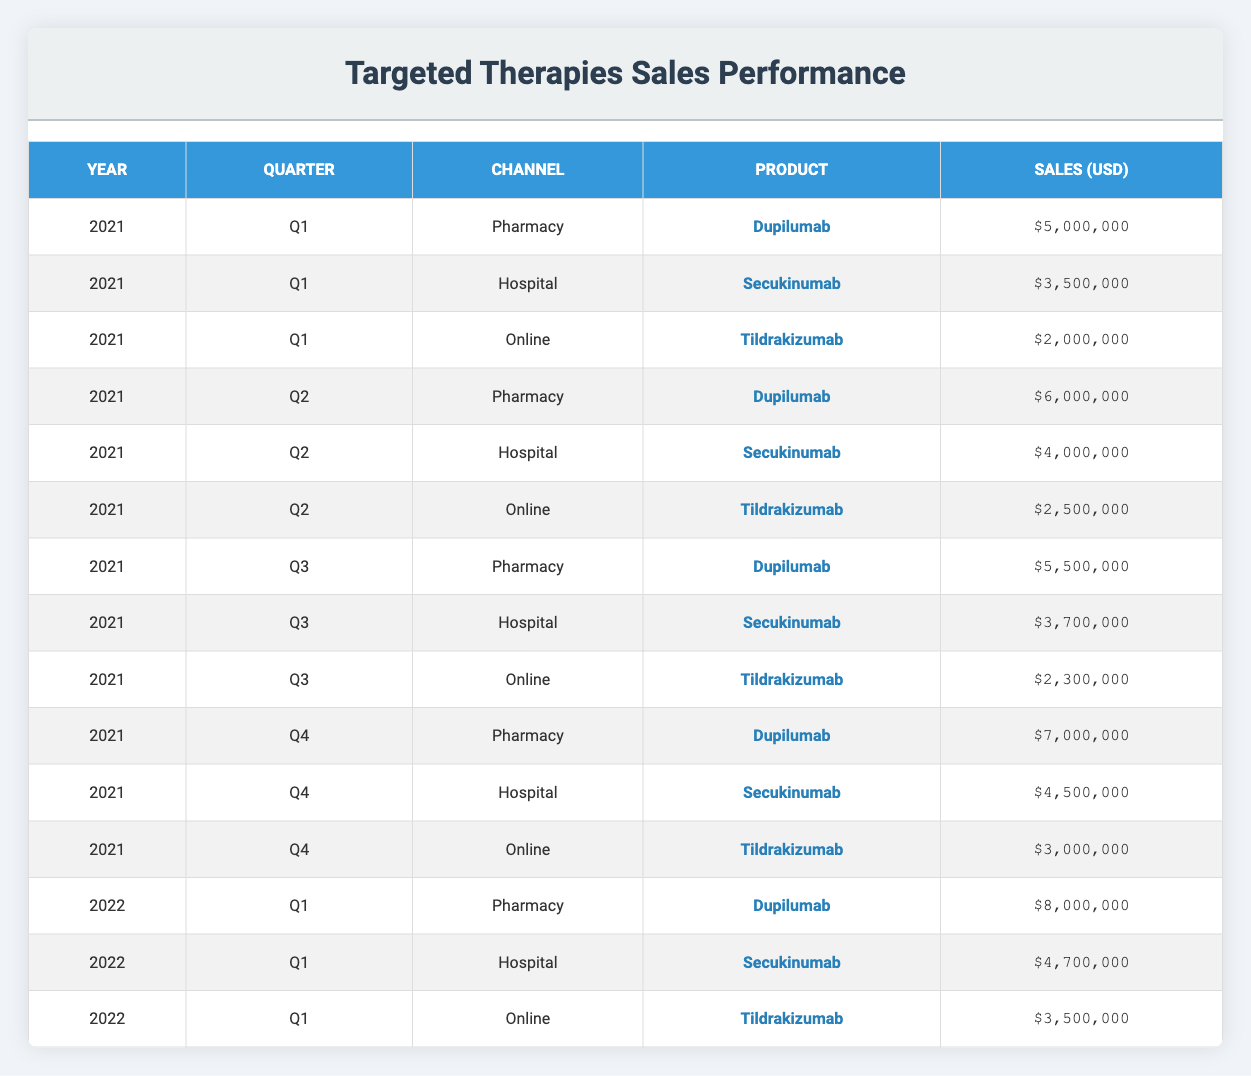What were the total sales for Dupilumab in 2021? To find the total sales for Dupilumab in 2021, I will add the sales from each quarter of that year. The sales values from the table are: Q1 $5,000,000, Q2 $6,000,000, Q3 $5,500,000, and Q4 $7,000,000. Summing these gives: $5,000,000 + $6,000,000 + $5,500,000 + $7,000,000 = $23,500,000.
Answer: $23,500,000 Which channel had the highest sales for Secukinumab in Q2 2021? In Q2 2021, the sales for Secukinumab by channel were: Hospital $4,000,000. There are no other channels listed for this product in Q2, so Hospital is the only channel for Secukinumab during this period.
Answer: Hospital What is the average sales value for Tildrakizumab across all quarters in 2021? The sales figures for Tildrakizumab in 2021 are: Q1 $2,000,000, Q2 $2,500,000, Q3 $2,300,000, and Q4 $3,000,000. To find the average, sum these sales: $2,000,000 + $2,500,000 + $2,300,000 + $3,000,000 = $9,800,000. Dividing this by 4 (the number of quarters) gives an average of $9,800,000 / 4 = $2,450,000.
Answer: $2,450,000 Did Pharmacy channel sales for Dupilumab increase from Q1 to Q4 in 2021? I need to compare the sales for Dupilumab in the Pharmacy channel from Q1 and Q4 of 2021. In Q1, the sales were $5,000,000, and in Q4, they were $7,000,000. Since $7,000,000 is greater than $5,000,000, there was indeed an increase.
Answer: Yes Which product had the lowest total sales in 2021 across all channels? To determine which product had the lowest total sales, I need to sum the sales for each product in 2021: 
- Dupilumab: $5,000,000 + $6,000,000 + $5,500,000 + $7,000,000 = $23,500,000 
- Secukinumab: $3,500,000 + $4,000,000 + $3,700,000 + $4,500,000 = $15,700,000 
- Tildrakizumab: $2,000,000 + $2,500,000 + $2,300,000 + $3,000,000 = $9,800,000 
Tildrakizumab has the lowest total sales of $9,800,000.
Answer: Tildrakizumab What were the total sales for all channels in Q1 2022? In Q1 2022, the sales across all channels were: Pharmacy $8,000,000, Hospital $4,700,000, and Online $3,500,000. Adding these up gives: $8,000,000 + $4,700,000 + $3,500,000 = $16,200,000.
Answer: $16,200,000 